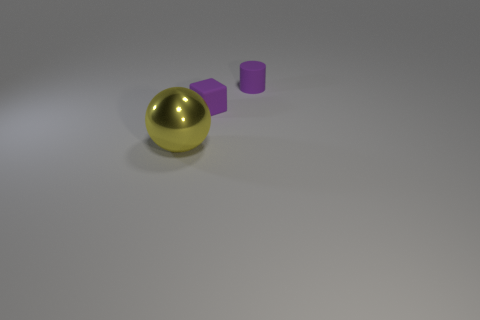There is a matte object in front of the purple cylinder; does it have the same color as the matte thing that is to the right of the small block?
Provide a short and direct response. Yes. There is a tiny thing that is behind the purple block; is its color the same as the matte block?
Your answer should be compact. Yes. Are there more large objects than big cyan things?
Ensure brevity in your answer.  Yes. How many rubber things are either big yellow things or tiny red cylinders?
Give a very brief answer. 0. How many small objects have the same color as the small matte cylinder?
Ensure brevity in your answer.  1. What material is the big thing that is in front of the small matte thing in front of the tiny object that is right of the matte block?
Your response must be concise. Metal. What is the color of the rubber thing in front of the purple matte thing that is behind the tiny purple rubber block?
Offer a very short reply. Purple. What number of small things are either purple matte cylinders or yellow balls?
Provide a short and direct response. 1. How many other tiny cylinders are made of the same material as the purple cylinder?
Give a very brief answer. 0. There is a object left of the cube; what is its size?
Your answer should be compact. Large. 